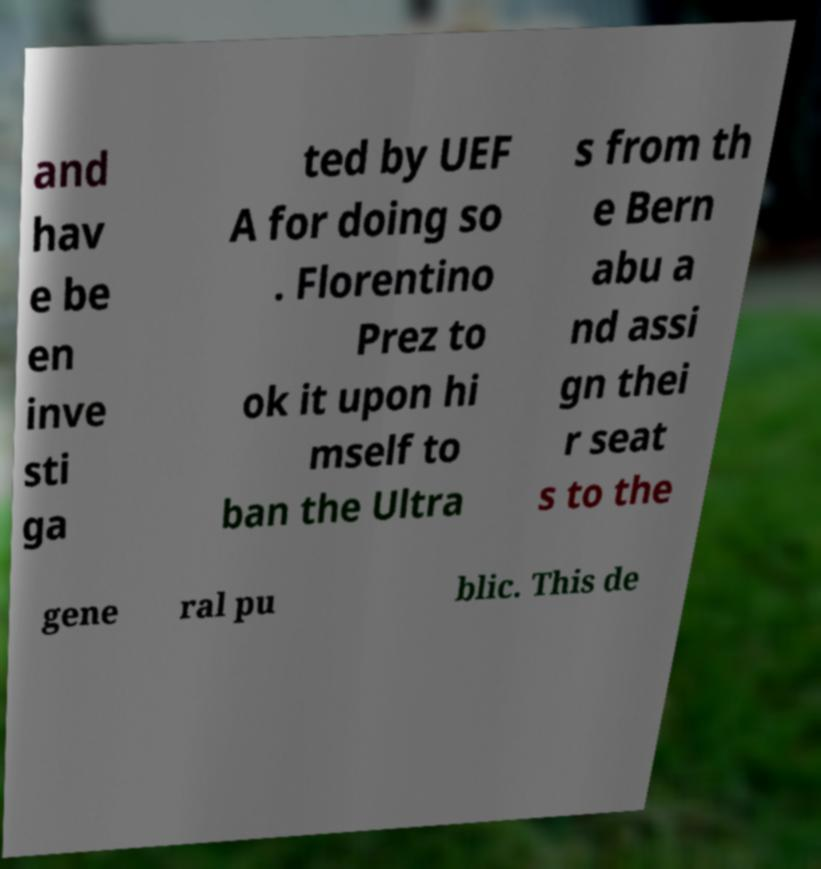For documentation purposes, I need the text within this image transcribed. Could you provide that? and hav e be en inve sti ga ted by UEF A for doing so . Florentino Prez to ok it upon hi mself to ban the Ultra s from th e Bern abu a nd assi gn thei r seat s to the gene ral pu blic. This de 